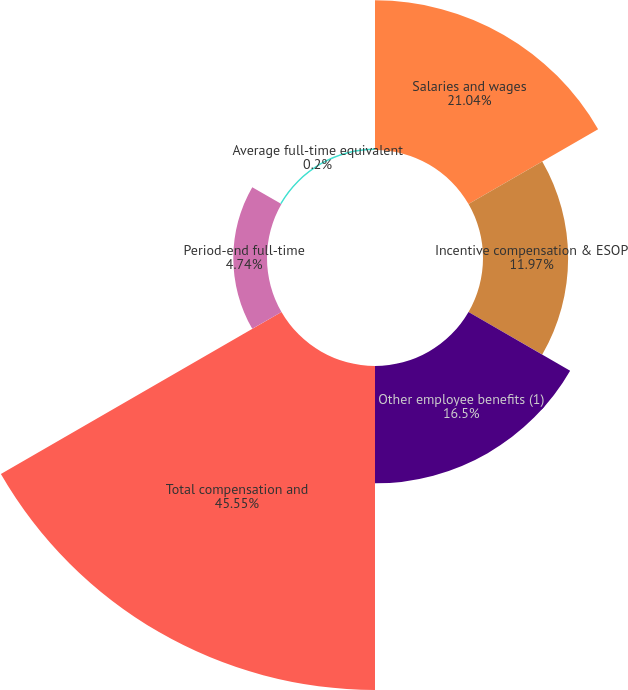Convert chart to OTSL. <chart><loc_0><loc_0><loc_500><loc_500><pie_chart><fcel>Salaries and wages<fcel>Incentive compensation & ESOP<fcel>Other employee benefits (1)<fcel>Total compensation and<fcel>Period-end full-time<fcel>Average full-time equivalent<nl><fcel>21.04%<fcel>11.97%<fcel>16.5%<fcel>45.56%<fcel>4.74%<fcel>0.2%<nl></chart> 